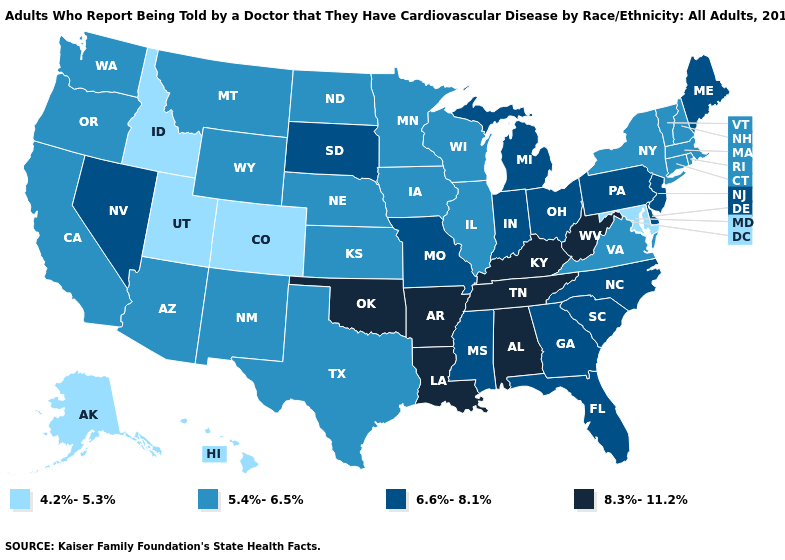Does Kentucky have a higher value than Arkansas?
Answer briefly. No. What is the highest value in the South ?
Short answer required. 8.3%-11.2%. Name the states that have a value in the range 5.4%-6.5%?
Quick response, please. Arizona, California, Connecticut, Illinois, Iowa, Kansas, Massachusetts, Minnesota, Montana, Nebraska, New Hampshire, New Mexico, New York, North Dakota, Oregon, Rhode Island, Texas, Vermont, Virginia, Washington, Wisconsin, Wyoming. Name the states that have a value in the range 4.2%-5.3%?
Answer briefly. Alaska, Colorado, Hawaii, Idaho, Maryland, Utah. What is the value of Virginia?
Short answer required. 5.4%-6.5%. What is the lowest value in states that border South Carolina?
Write a very short answer. 6.6%-8.1%. Does Ohio have the same value as Iowa?
Keep it brief. No. What is the value of Missouri?
Concise answer only. 6.6%-8.1%. Name the states that have a value in the range 4.2%-5.3%?
Concise answer only. Alaska, Colorado, Hawaii, Idaho, Maryland, Utah. What is the lowest value in the USA?
Keep it brief. 4.2%-5.3%. What is the value of Maine?
Answer briefly. 6.6%-8.1%. Which states have the highest value in the USA?
Short answer required. Alabama, Arkansas, Kentucky, Louisiana, Oklahoma, Tennessee, West Virginia. Which states have the lowest value in the USA?
Concise answer only. Alaska, Colorado, Hawaii, Idaho, Maryland, Utah. Name the states that have a value in the range 4.2%-5.3%?
Keep it brief. Alaska, Colorado, Hawaii, Idaho, Maryland, Utah. 